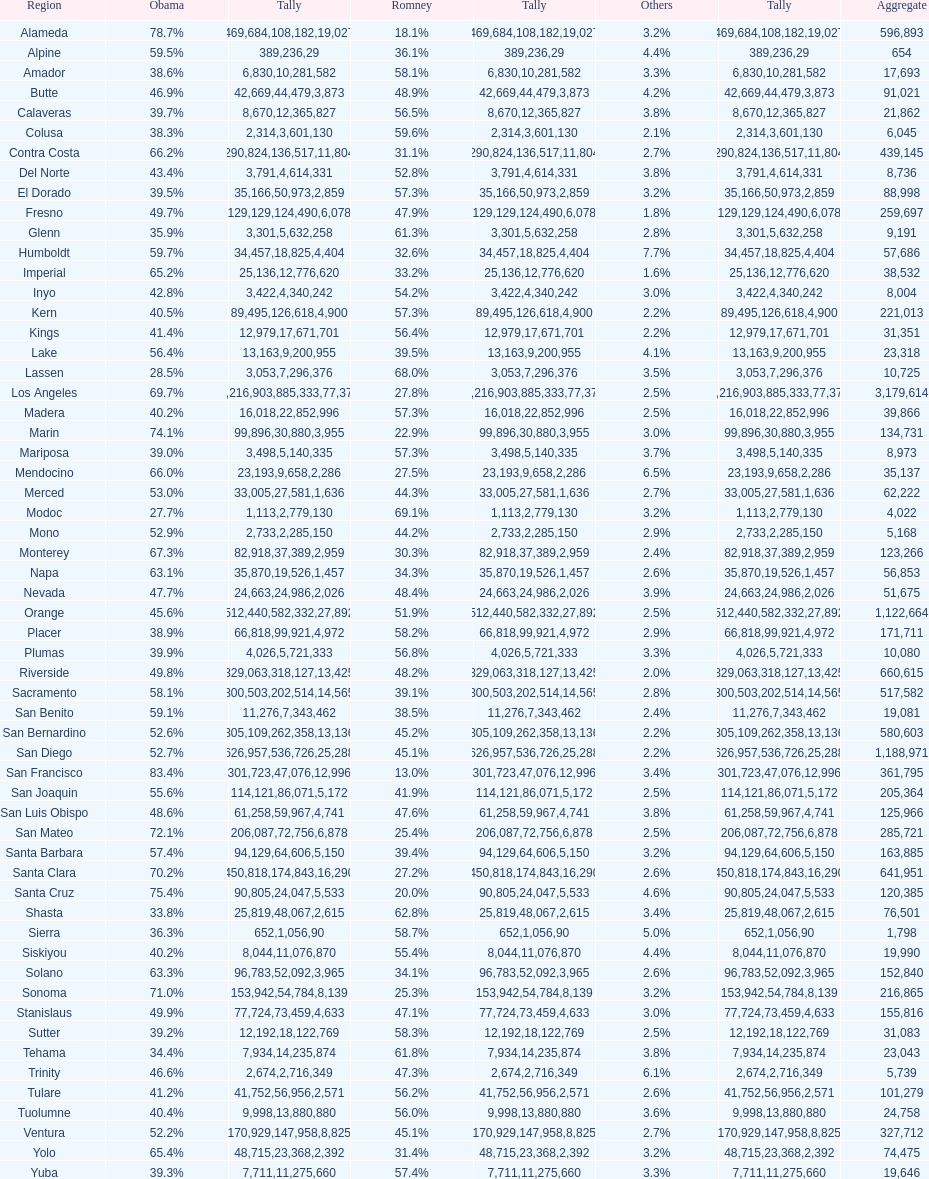Which county had the most total votes? Los Angeles. 